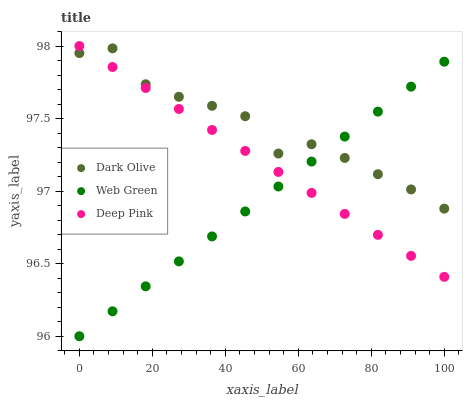Does Web Green have the minimum area under the curve?
Answer yes or no. Yes. Does Dark Olive have the maximum area under the curve?
Answer yes or no. Yes. Does Deep Pink have the minimum area under the curve?
Answer yes or no. No. Does Deep Pink have the maximum area under the curve?
Answer yes or no. No. Is Web Green the smoothest?
Answer yes or no. Yes. Is Dark Olive the roughest?
Answer yes or no. Yes. Is Deep Pink the smoothest?
Answer yes or no. No. Is Deep Pink the roughest?
Answer yes or no. No. Does Web Green have the lowest value?
Answer yes or no. Yes. Does Deep Pink have the lowest value?
Answer yes or no. No. Does Deep Pink have the highest value?
Answer yes or no. Yes. Does Web Green have the highest value?
Answer yes or no. No. Does Deep Pink intersect Dark Olive?
Answer yes or no. Yes. Is Deep Pink less than Dark Olive?
Answer yes or no. No. Is Deep Pink greater than Dark Olive?
Answer yes or no. No. 